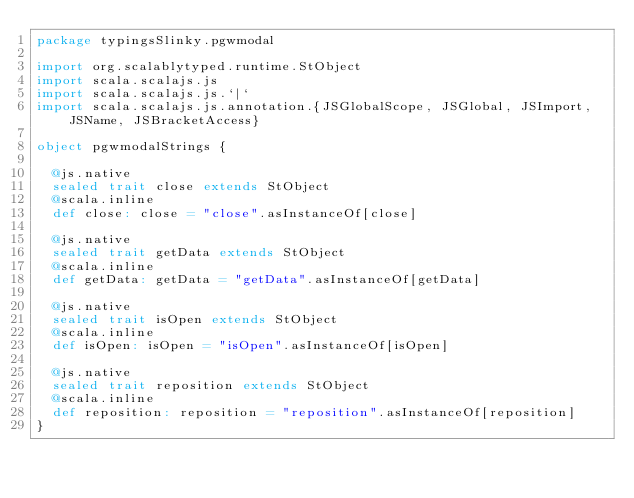Convert code to text. <code><loc_0><loc_0><loc_500><loc_500><_Scala_>package typingsSlinky.pgwmodal

import org.scalablytyped.runtime.StObject
import scala.scalajs.js
import scala.scalajs.js.`|`
import scala.scalajs.js.annotation.{JSGlobalScope, JSGlobal, JSImport, JSName, JSBracketAccess}

object pgwmodalStrings {
  
  @js.native
  sealed trait close extends StObject
  @scala.inline
  def close: close = "close".asInstanceOf[close]
  
  @js.native
  sealed trait getData extends StObject
  @scala.inline
  def getData: getData = "getData".asInstanceOf[getData]
  
  @js.native
  sealed trait isOpen extends StObject
  @scala.inline
  def isOpen: isOpen = "isOpen".asInstanceOf[isOpen]
  
  @js.native
  sealed trait reposition extends StObject
  @scala.inline
  def reposition: reposition = "reposition".asInstanceOf[reposition]
}
</code> 